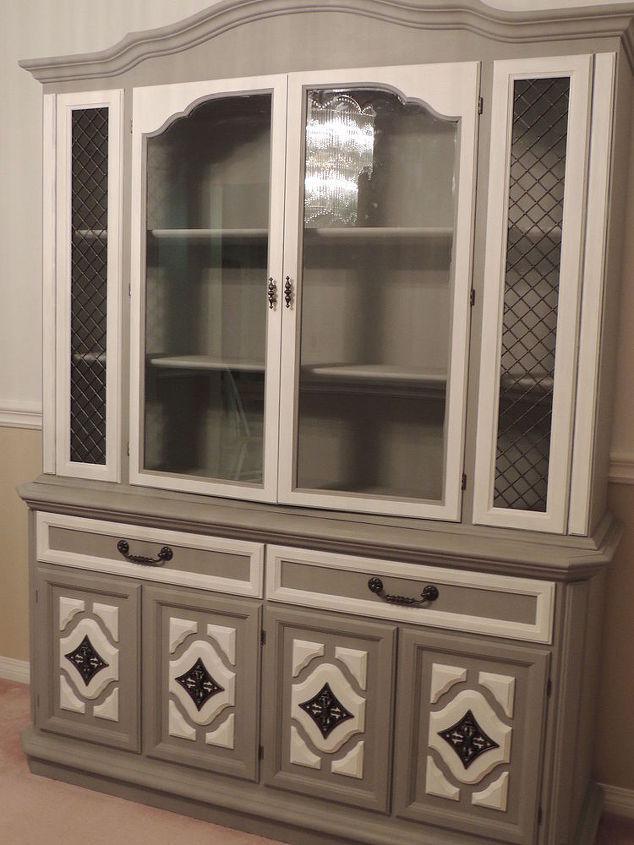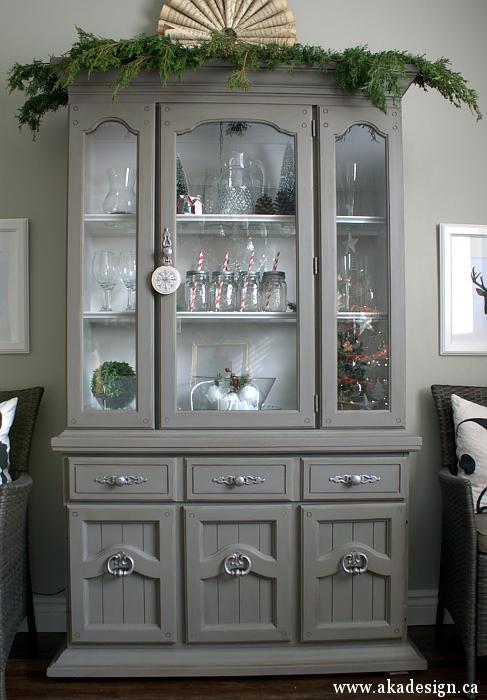The first image is the image on the left, the second image is the image on the right. For the images shown, is this caption "There is at least one hutch that is painted dark gray." true? Answer yes or no. Yes. 